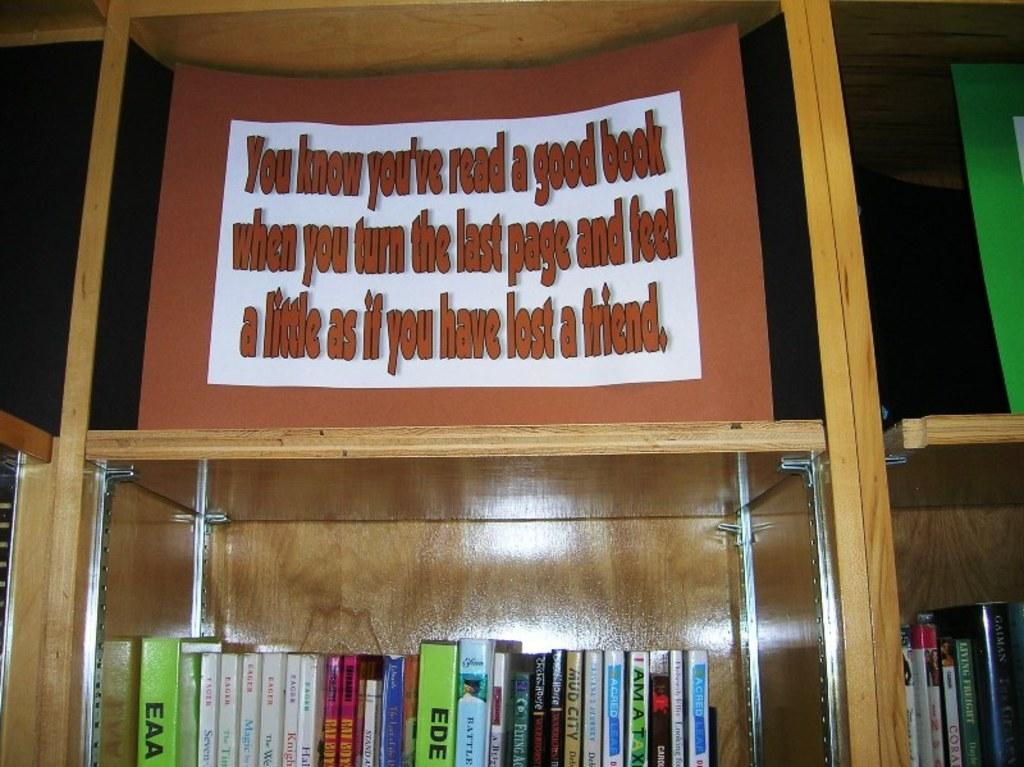What objects are present in the image? There are books and a card with text in the image. How are the books arranged in the image? The books are in a rack. Where is the card located in relation to the books? The card is above the books. Can you see any tubs or soaps in the image? There are no tubs or soaps present in the image. Is there a home visible in the image? The image does not show a home; it features books in a rack and a card with text. 